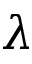Convert formula to latex. <formula><loc_0><loc_0><loc_500><loc_500>\lambda</formula> 